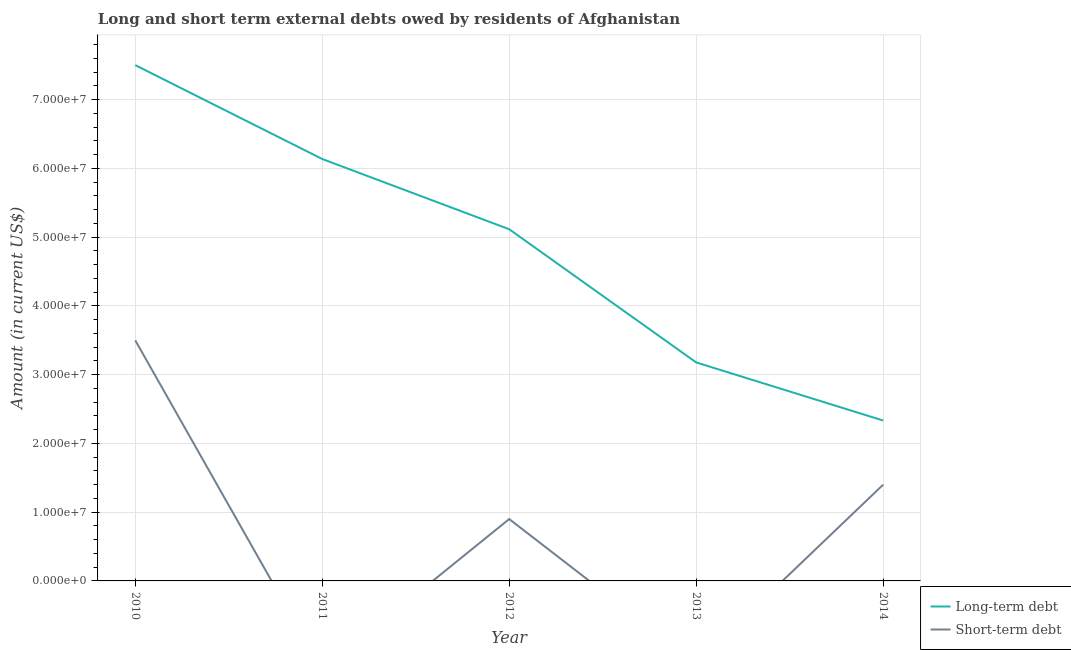What is the short-term debts owed by residents in 2011?
Ensure brevity in your answer.  0. Across all years, what is the maximum short-term debts owed by residents?
Provide a succinct answer. 3.50e+07. Across all years, what is the minimum long-term debts owed by residents?
Keep it short and to the point. 2.33e+07. What is the total long-term debts owed by residents in the graph?
Offer a terse response. 2.43e+08. What is the difference between the long-term debts owed by residents in 2012 and that in 2014?
Provide a short and direct response. 2.78e+07. What is the difference between the long-term debts owed by residents in 2011 and the short-term debts owed by residents in 2010?
Make the answer very short. 2.64e+07. What is the average long-term debts owed by residents per year?
Provide a short and direct response. 4.85e+07. In the year 2010, what is the difference between the short-term debts owed by residents and long-term debts owed by residents?
Provide a short and direct response. -4.00e+07. What is the ratio of the long-term debts owed by residents in 2010 to that in 2012?
Provide a short and direct response. 1.47. Is the difference between the long-term debts owed by residents in 2012 and 2014 greater than the difference between the short-term debts owed by residents in 2012 and 2014?
Provide a short and direct response. Yes. What is the difference between the highest and the second highest long-term debts owed by residents?
Provide a succinct answer. 1.37e+07. What is the difference between the highest and the lowest long-term debts owed by residents?
Your answer should be compact. 5.17e+07. Is the short-term debts owed by residents strictly greater than the long-term debts owed by residents over the years?
Make the answer very short. No. Is the short-term debts owed by residents strictly less than the long-term debts owed by residents over the years?
Make the answer very short. Yes. What is the difference between two consecutive major ticks on the Y-axis?
Keep it short and to the point. 1.00e+07. Are the values on the major ticks of Y-axis written in scientific E-notation?
Provide a succinct answer. Yes. Does the graph contain any zero values?
Your response must be concise. Yes. Does the graph contain grids?
Keep it short and to the point. Yes. How many legend labels are there?
Offer a terse response. 2. How are the legend labels stacked?
Provide a short and direct response. Vertical. What is the title of the graph?
Offer a terse response. Long and short term external debts owed by residents of Afghanistan. Does "Female labourers" appear as one of the legend labels in the graph?
Make the answer very short. No. What is the label or title of the X-axis?
Give a very brief answer. Year. What is the Amount (in current US$) of Long-term debt in 2010?
Your answer should be very brief. 7.50e+07. What is the Amount (in current US$) of Short-term debt in 2010?
Offer a terse response. 3.50e+07. What is the Amount (in current US$) of Long-term debt in 2011?
Give a very brief answer. 6.14e+07. What is the Amount (in current US$) in Long-term debt in 2012?
Your answer should be very brief. 5.12e+07. What is the Amount (in current US$) in Short-term debt in 2012?
Your response must be concise. 9.00e+06. What is the Amount (in current US$) in Long-term debt in 2013?
Ensure brevity in your answer.  3.18e+07. What is the Amount (in current US$) in Short-term debt in 2013?
Offer a very short reply. 0. What is the Amount (in current US$) of Long-term debt in 2014?
Offer a very short reply. 2.33e+07. What is the Amount (in current US$) in Short-term debt in 2014?
Your response must be concise. 1.40e+07. Across all years, what is the maximum Amount (in current US$) of Long-term debt?
Your response must be concise. 7.50e+07. Across all years, what is the maximum Amount (in current US$) of Short-term debt?
Provide a succinct answer. 3.50e+07. Across all years, what is the minimum Amount (in current US$) in Long-term debt?
Offer a very short reply. 2.33e+07. Across all years, what is the minimum Amount (in current US$) in Short-term debt?
Make the answer very short. 0. What is the total Amount (in current US$) in Long-term debt in the graph?
Your response must be concise. 2.43e+08. What is the total Amount (in current US$) of Short-term debt in the graph?
Ensure brevity in your answer.  5.80e+07. What is the difference between the Amount (in current US$) in Long-term debt in 2010 and that in 2011?
Provide a succinct answer. 1.37e+07. What is the difference between the Amount (in current US$) of Long-term debt in 2010 and that in 2012?
Give a very brief answer. 2.39e+07. What is the difference between the Amount (in current US$) of Short-term debt in 2010 and that in 2012?
Keep it short and to the point. 2.60e+07. What is the difference between the Amount (in current US$) in Long-term debt in 2010 and that in 2013?
Offer a very short reply. 4.33e+07. What is the difference between the Amount (in current US$) of Long-term debt in 2010 and that in 2014?
Offer a very short reply. 5.17e+07. What is the difference between the Amount (in current US$) in Short-term debt in 2010 and that in 2014?
Offer a very short reply. 2.10e+07. What is the difference between the Amount (in current US$) of Long-term debt in 2011 and that in 2012?
Your response must be concise. 1.02e+07. What is the difference between the Amount (in current US$) of Long-term debt in 2011 and that in 2013?
Provide a succinct answer. 2.96e+07. What is the difference between the Amount (in current US$) in Long-term debt in 2011 and that in 2014?
Make the answer very short. 3.80e+07. What is the difference between the Amount (in current US$) in Long-term debt in 2012 and that in 2013?
Provide a succinct answer. 1.94e+07. What is the difference between the Amount (in current US$) in Long-term debt in 2012 and that in 2014?
Give a very brief answer. 2.78e+07. What is the difference between the Amount (in current US$) of Short-term debt in 2012 and that in 2014?
Offer a very short reply. -5.00e+06. What is the difference between the Amount (in current US$) of Long-term debt in 2013 and that in 2014?
Offer a very short reply. 8.45e+06. What is the difference between the Amount (in current US$) in Long-term debt in 2010 and the Amount (in current US$) in Short-term debt in 2012?
Provide a short and direct response. 6.60e+07. What is the difference between the Amount (in current US$) of Long-term debt in 2010 and the Amount (in current US$) of Short-term debt in 2014?
Make the answer very short. 6.10e+07. What is the difference between the Amount (in current US$) in Long-term debt in 2011 and the Amount (in current US$) in Short-term debt in 2012?
Keep it short and to the point. 5.24e+07. What is the difference between the Amount (in current US$) of Long-term debt in 2011 and the Amount (in current US$) of Short-term debt in 2014?
Offer a terse response. 4.74e+07. What is the difference between the Amount (in current US$) of Long-term debt in 2012 and the Amount (in current US$) of Short-term debt in 2014?
Your answer should be very brief. 3.72e+07. What is the difference between the Amount (in current US$) in Long-term debt in 2013 and the Amount (in current US$) in Short-term debt in 2014?
Your response must be concise. 1.78e+07. What is the average Amount (in current US$) in Long-term debt per year?
Your response must be concise. 4.85e+07. What is the average Amount (in current US$) of Short-term debt per year?
Keep it short and to the point. 1.16e+07. In the year 2010, what is the difference between the Amount (in current US$) of Long-term debt and Amount (in current US$) of Short-term debt?
Keep it short and to the point. 4.00e+07. In the year 2012, what is the difference between the Amount (in current US$) of Long-term debt and Amount (in current US$) of Short-term debt?
Your answer should be very brief. 4.22e+07. In the year 2014, what is the difference between the Amount (in current US$) in Long-term debt and Amount (in current US$) in Short-term debt?
Your answer should be very brief. 9.34e+06. What is the ratio of the Amount (in current US$) of Long-term debt in 2010 to that in 2011?
Offer a terse response. 1.22. What is the ratio of the Amount (in current US$) of Long-term debt in 2010 to that in 2012?
Offer a very short reply. 1.47. What is the ratio of the Amount (in current US$) in Short-term debt in 2010 to that in 2012?
Keep it short and to the point. 3.89. What is the ratio of the Amount (in current US$) in Long-term debt in 2010 to that in 2013?
Ensure brevity in your answer.  2.36. What is the ratio of the Amount (in current US$) in Long-term debt in 2010 to that in 2014?
Offer a terse response. 3.22. What is the ratio of the Amount (in current US$) in Long-term debt in 2011 to that in 2012?
Provide a succinct answer. 1.2. What is the ratio of the Amount (in current US$) in Long-term debt in 2011 to that in 2013?
Provide a succinct answer. 1.93. What is the ratio of the Amount (in current US$) of Long-term debt in 2011 to that in 2014?
Make the answer very short. 2.63. What is the ratio of the Amount (in current US$) in Long-term debt in 2012 to that in 2013?
Make the answer very short. 1.61. What is the ratio of the Amount (in current US$) in Long-term debt in 2012 to that in 2014?
Offer a terse response. 2.19. What is the ratio of the Amount (in current US$) in Short-term debt in 2012 to that in 2014?
Your answer should be compact. 0.64. What is the ratio of the Amount (in current US$) of Long-term debt in 2013 to that in 2014?
Provide a short and direct response. 1.36. What is the difference between the highest and the second highest Amount (in current US$) in Long-term debt?
Offer a very short reply. 1.37e+07. What is the difference between the highest and the second highest Amount (in current US$) of Short-term debt?
Ensure brevity in your answer.  2.10e+07. What is the difference between the highest and the lowest Amount (in current US$) in Long-term debt?
Provide a short and direct response. 5.17e+07. What is the difference between the highest and the lowest Amount (in current US$) of Short-term debt?
Make the answer very short. 3.50e+07. 